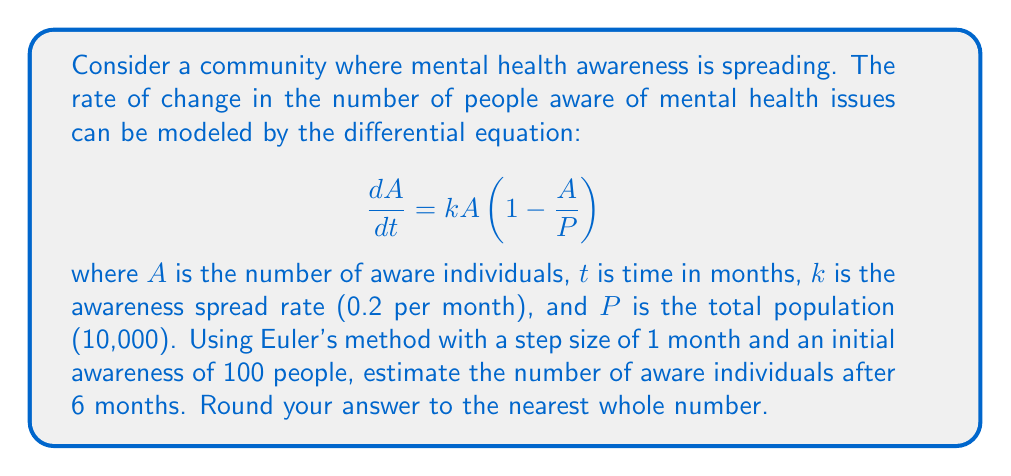What is the answer to this math problem? 1) Euler's method is given by the formula:
   $$A_{n+1} = A_n + h \cdot f(t_n, A_n)$$
   where $h$ is the step size and $f(t, A) = kA(1-\frac{A}{P})$

2) Given: $k = 0.2$, $P = 10,000$, $h = 1$ month, $A_0 = 100$

3) We'll iterate 6 times for 6 months:

   Month 0: $A_0 = 100$
   
   Month 1: $A_1 = 100 + 1 \cdot 0.2 \cdot 100(1-\frac{100}{10000}) = 119.8$
   
   Month 2: $A_2 = 119.8 + 1 \cdot 0.2 \cdot 119.8(1-\frac{119.8}{10000}) = 143.28$
   
   Month 3: $A_3 = 143.28 + 1 \cdot 0.2 \cdot 143.28(1-\frac{143.28}{10000}) = 171.22$
   
   Month 4: $A_4 = 171.22 + 1 \cdot 0.2 \cdot 171.22(1-\frac{171.22}{10000}) = 204.38$
   
   Month 5: $A_5 = 204.38 + 1 \cdot 0.2 \cdot 204.38(1-\frac{204.38}{10000}) = 243.56$
   
   Month 6: $A_6 = 243.56 + 1 \cdot 0.2 \cdot 243.56(1-\frac{243.56}{10000}) = 289.54$

4) Rounding to the nearest whole number: 290
Answer: 290 